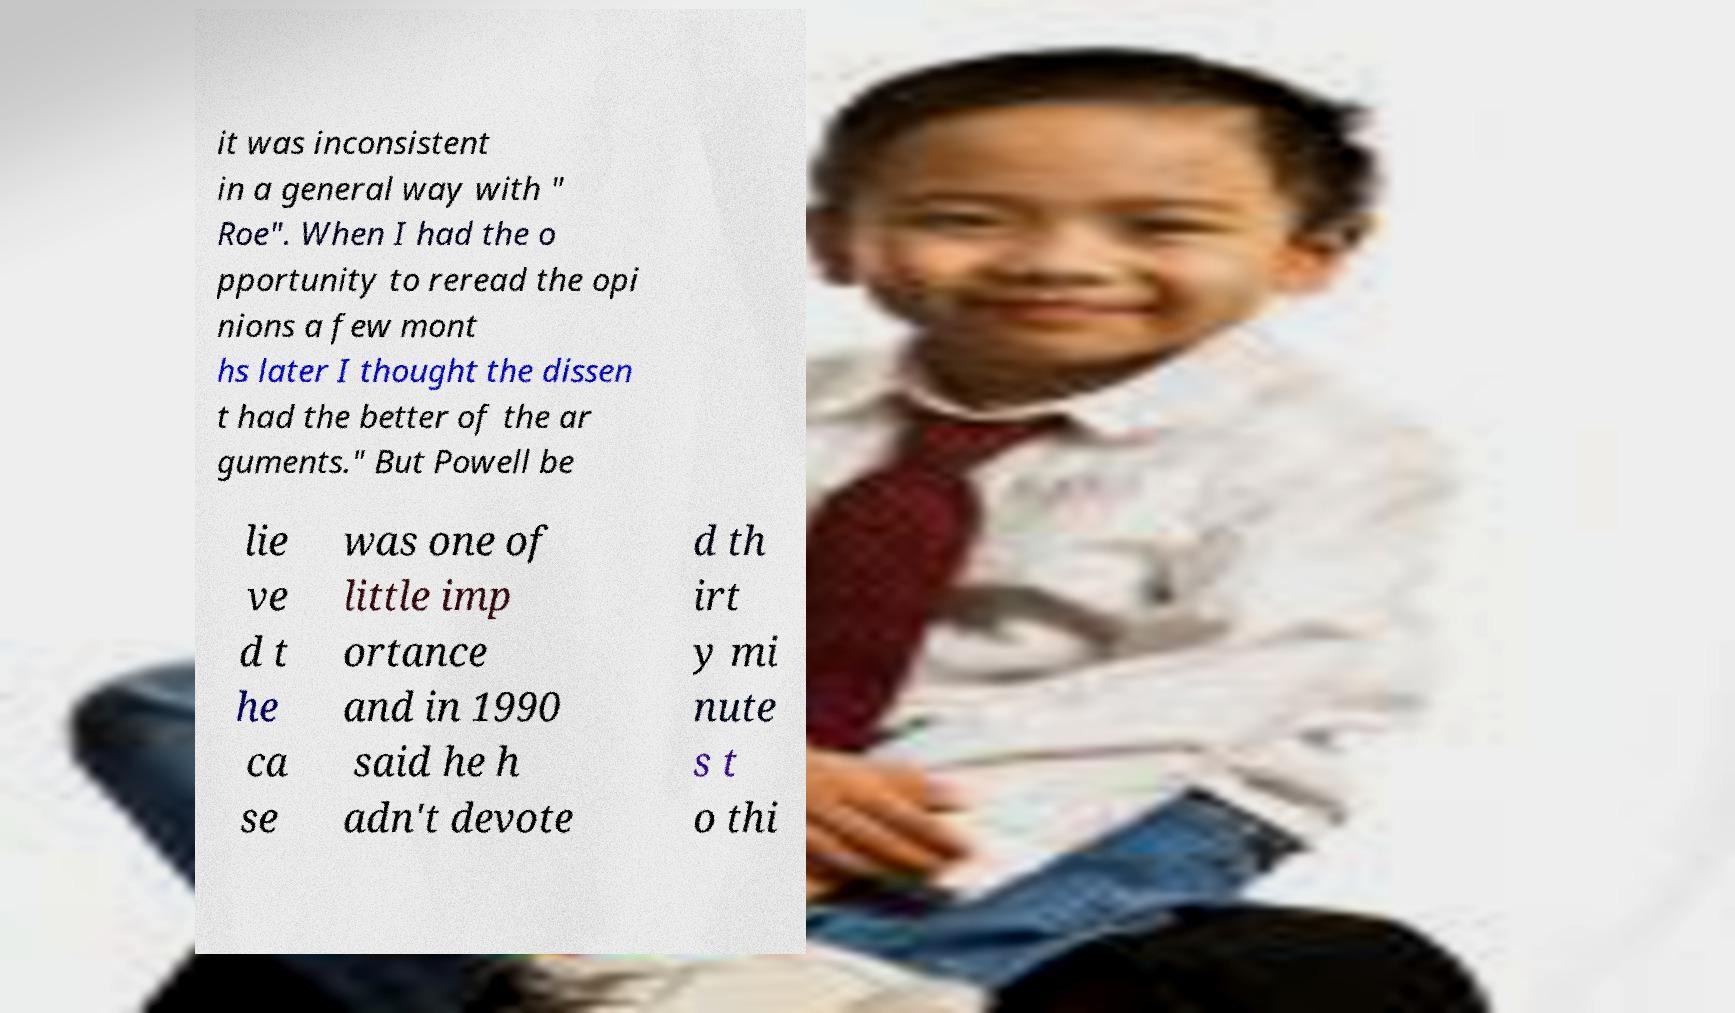Could you assist in decoding the text presented in this image and type it out clearly? it was inconsistent in a general way with " Roe". When I had the o pportunity to reread the opi nions a few mont hs later I thought the dissen t had the better of the ar guments." But Powell be lie ve d t he ca se was one of little imp ortance and in 1990 said he h adn't devote d th irt y mi nute s t o thi 